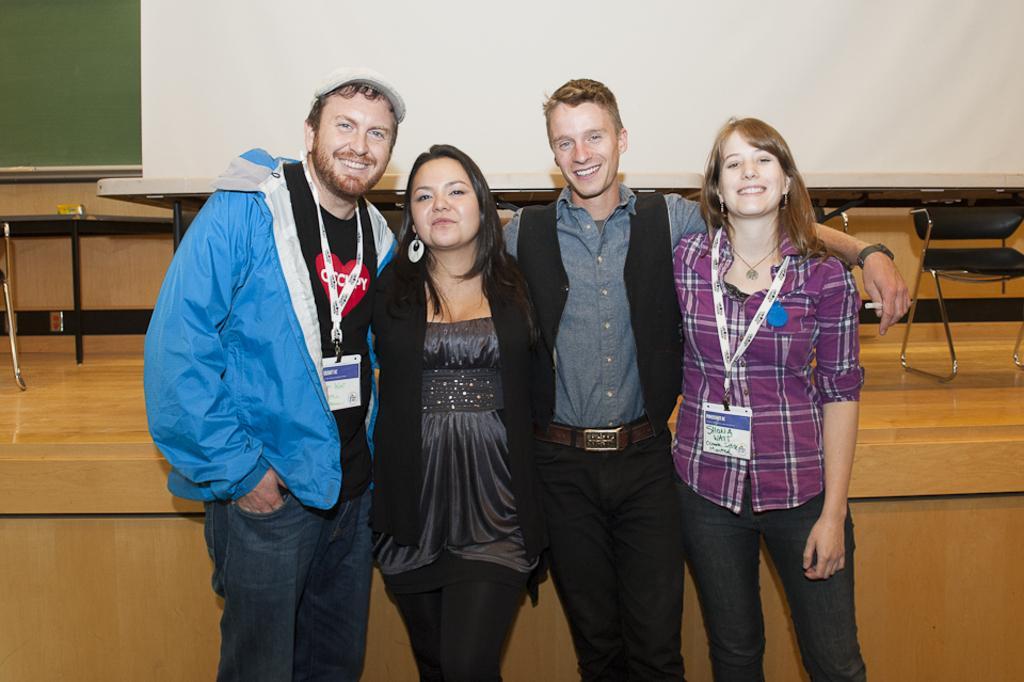In one or two sentences, can you explain what this image depicts? In the center of the image there are four persons standing. In the background there is a board, wall, table and chairs. 